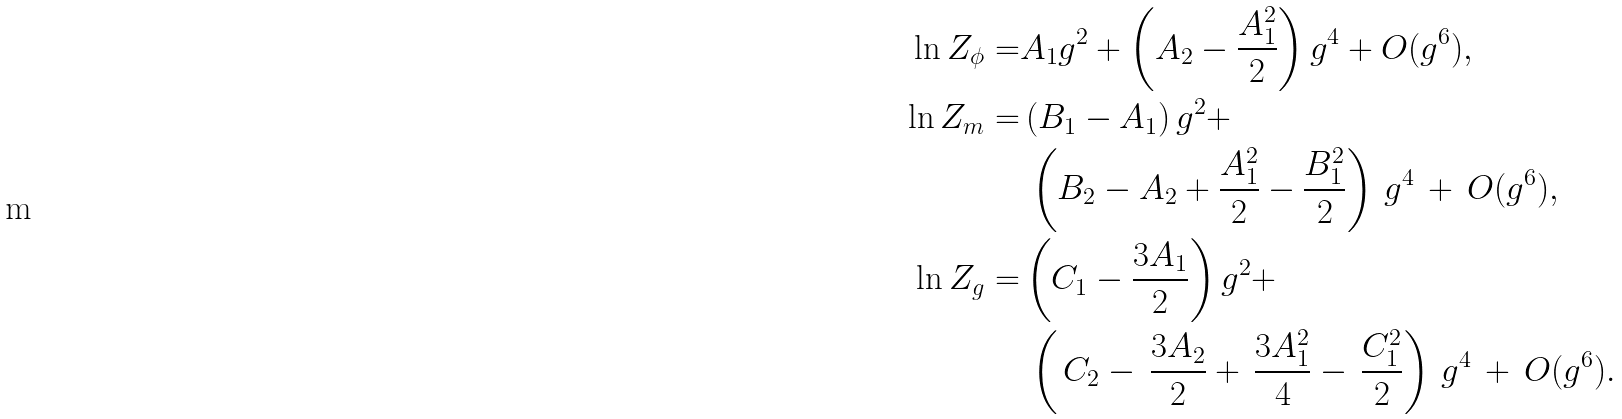<formula> <loc_0><loc_0><loc_500><loc_500>\, \ln Z _ { \phi } = & A _ { 1 } g ^ { 2 } + \left ( A _ { 2 } - \frac { A _ { 1 } ^ { 2 } } { 2 } \right ) g ^ { 4 } + O ( g ^ { 6 } ) , \\ \, \ln Z _ { m } = & \left ( B _ { 1 } - A _ { 1 } \right ) g ^ { 2 } + \\ & \, \left ( B _ { 2 } - A _ { 2 } + \frac { A _ { 1 } ^ { 2 } } { 2 } - \frac { B _ { 1 } ^ { 2 } } { 2 } \right ) \, g ^ { 4 } \, + \, O ( g ^ { 6 } ) , \\ \, \ln Z _ { g } = & \left ( C _ { 1 } - \frac { 3 A _ { 1 } } { 2 } \right ) g ^ { 2 } + \\ & \, \left ( \, C _ { 2 } - \, \frac { 3 A _ { 2 } } { 2 } + \, \frac { 3 A _ { 1 } ^ { 2 } } { 4 } - \, \frac { C _ { 1 } ^ { 2 } } { 2 } \right ) \, g ^ { 4 } \, + \, O ( g ^ { 6 } ) .</formula> 